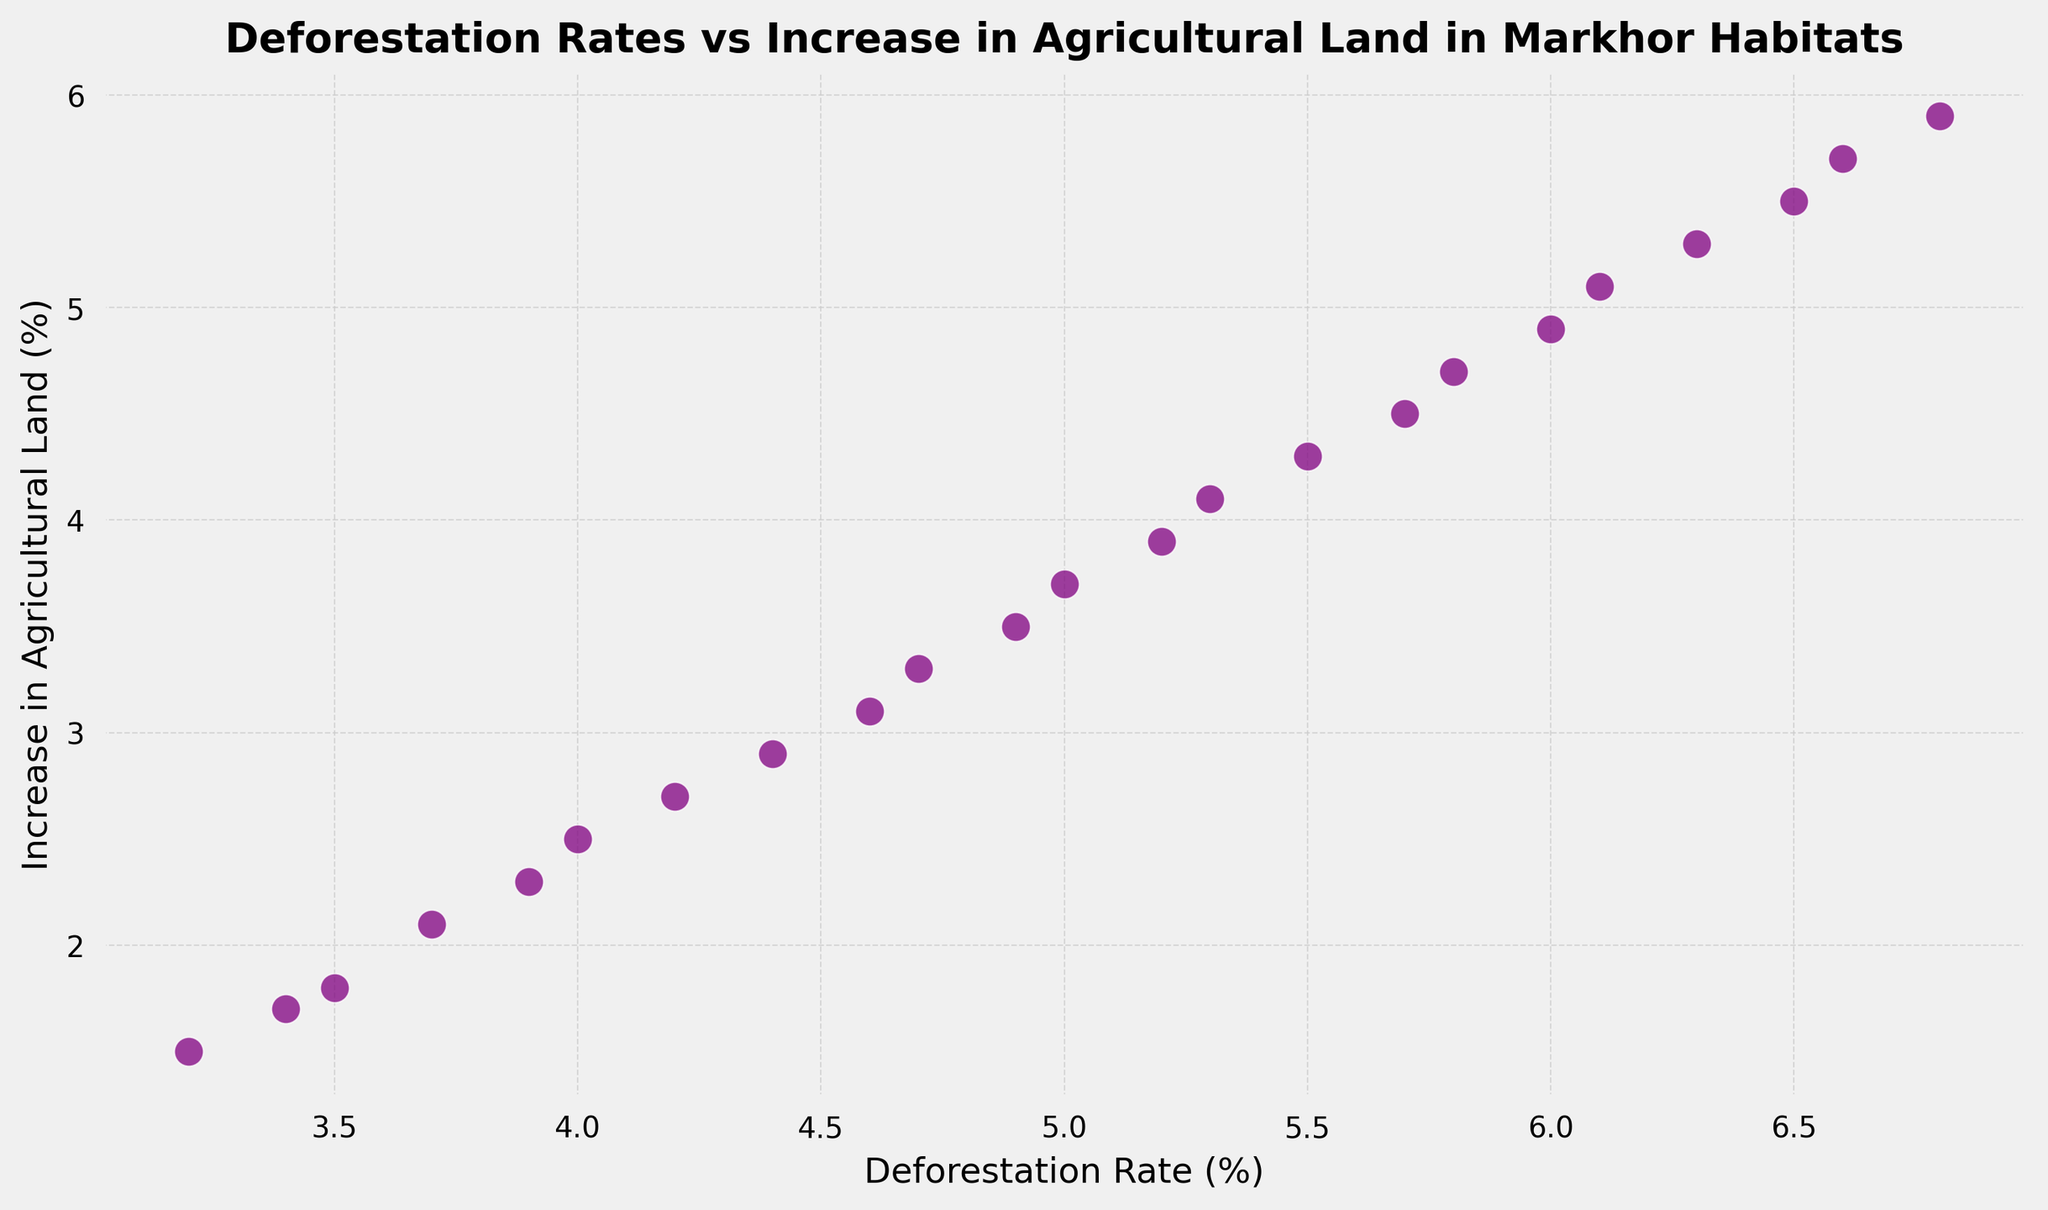What is the relationship between the deforestation rate and the increase in agricultural land? To determine the relationship, observe how the points are distributed. All points show a trend where higher deforestation rates correspond with higher increases in agricultural land percentages. This suggests a positive correlation.
Answer: Positive correlation What is the deforestation rate when the increase in agricultural land is 4.5%? Find the point where the increase in agricultural land percentage is 4.5% and trace it to see the corresponding deforestation rate. At this point, the deforestation rate is approximately 5.7%.
Answer: 5.7% How much has the deforestation rate increased from 2000 to 2022? The deforestation rate in 2000 is 3.2%, and in 2022 it is 6.8%. The increase is calculated as 6.8% - 3.2% = 3.6%.
Answer: 3.6% Is there any year where the increase in agricultural land stopped increasing despite an increase in deforestation rate? Reviewing the scatter plot, every increase in the deforestation rate is accompanied by an increase in the percentage of agricultural land, showing no anomalies where agricultural land stops increasing.
Answer: No What is the highest deforestation rate observed in the data? The maximum value on the x-axis representing deforestation rates is around 6.8%.
Answer: 6.8% When the deforestation rate is 5%, what is the corresponding increase in agricultural land? Locate the point where the deforestation rate is 5% and see the corresponding value on the y-axis. It is approximately 3.7%.
Answer: 3.7% What is the trend between the deforestation rate and the increase in agricultural land from 2010 to 2015? From 2010 to 2015, the scatter plot shows that the deforestation rate increased from 4.9% to 5.7%, and the agricultural land percentage also increased from 3.5% to 4.5%, indicating a consistent upward trend.
Answer: Upward trend Compare the deforestation rates versus increase in agricultural land from 2000 to 2010 and from 2011 to 2022. Which period experienced a higher rate of increase in agricultural land? From 2000 to 2010, the deforestation rate increased by 1.7% (3.2% to 4.9%) and the agricultural land by 2% (1.5% to 3.5%). From 2011 to 2022, the deforestation rate increased by 1.8% (5.0% to 6.8%) and the agricultural land by 2.2% (3.7% to 5.9%). Thus, the latter period experienced a higher rate of increase in agricultural land.
Answer: 2011 to 2022 Was there any time period where the increase in agricultural land exhibits a dramatic rise corresponding to a slight increase in deforestation rate? The increase in agricultural land is relatively proportional to the increments in deforestation rates. No dramatic rises in agricultural land correspond to slight increases in deforestation rates.
Answer: No 